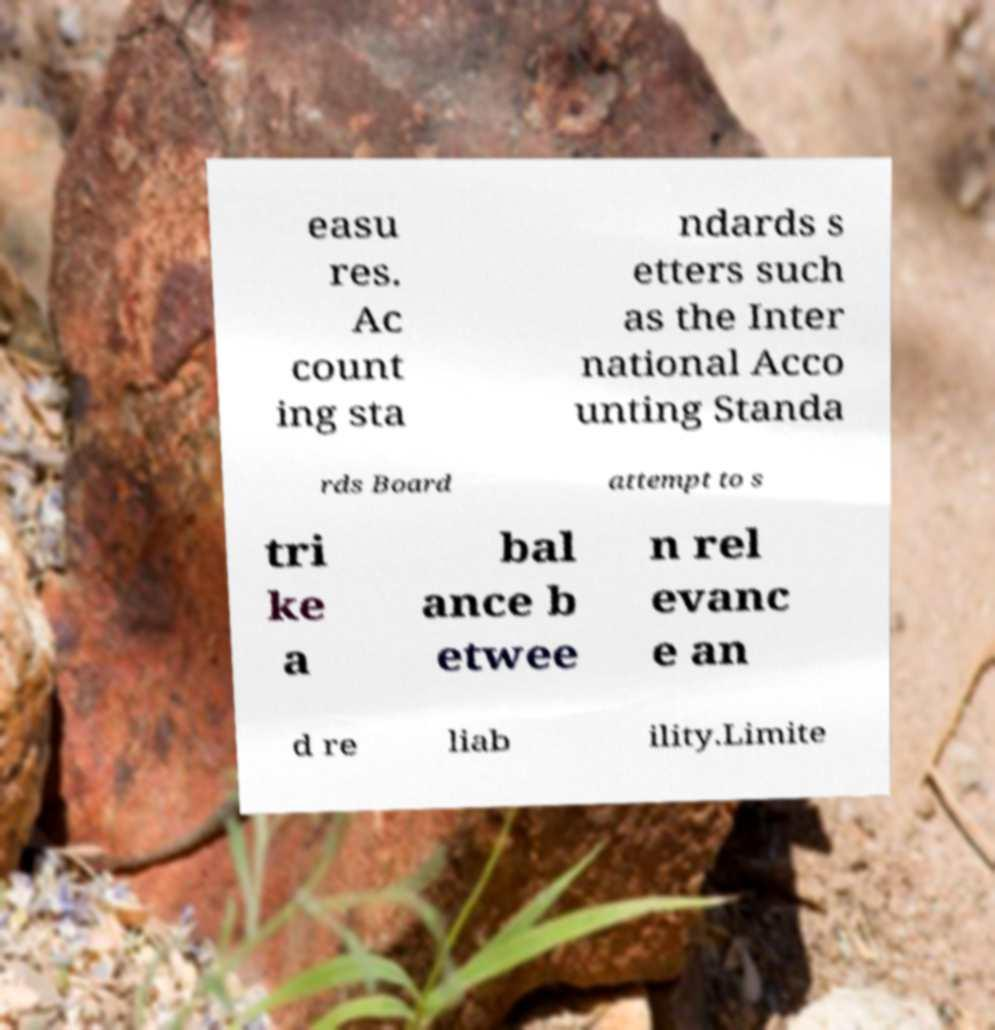Could you assist in decoding the text presented in this image and type it out clearly? easu res. Ac count ing sta ndards s etters such as the Inter national Acco unting Standa rds Board attempt to s tri ke a bal ance b etwee n rel evanc e an d re liab ility.Limite 